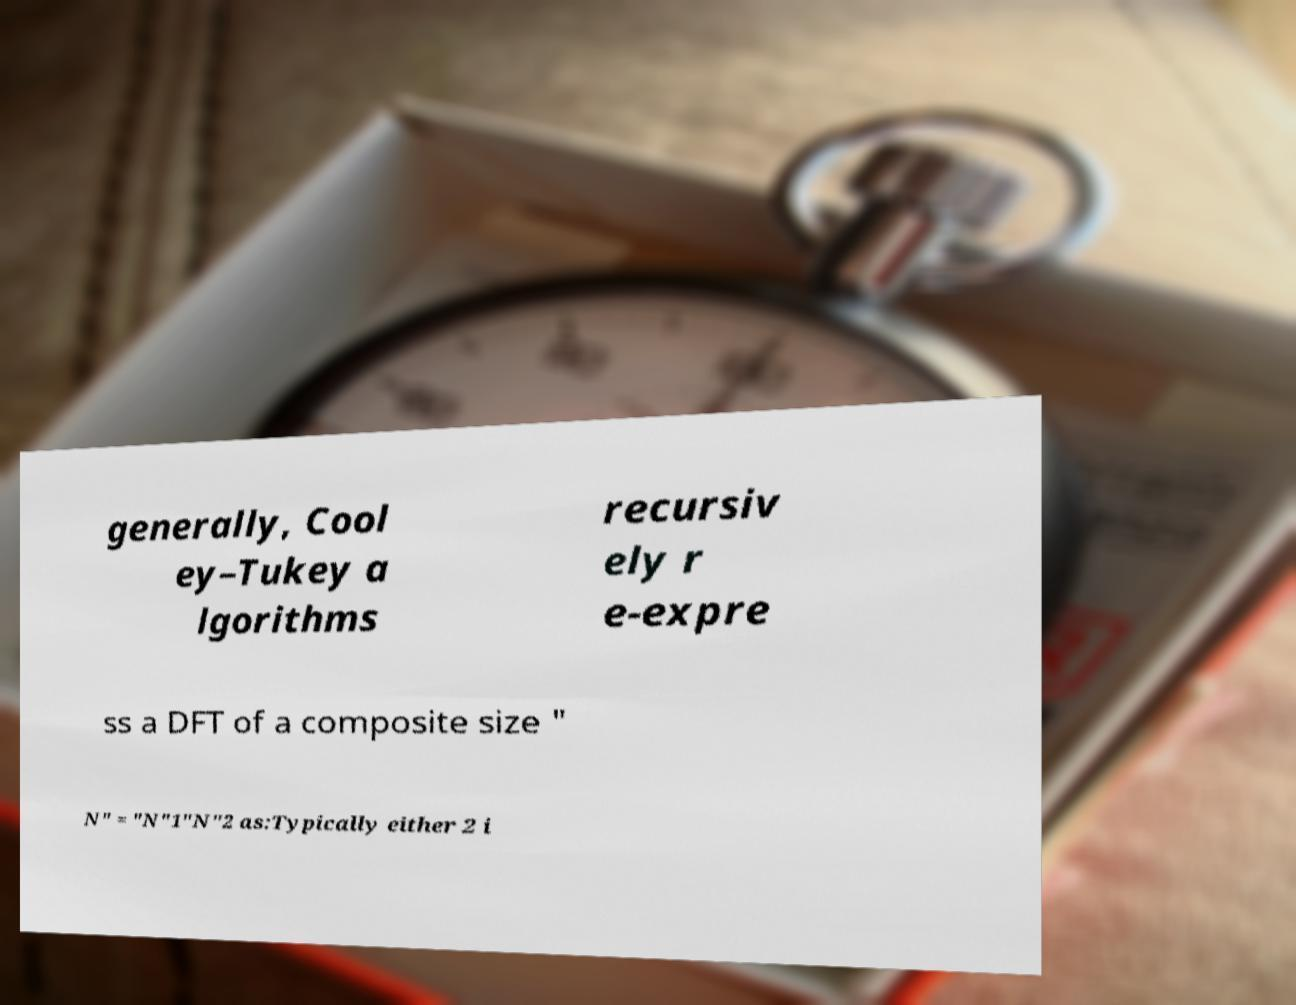For documentation purposes, I need the text within this image transcribed. Could you provide that? generally, Cool ey–Tukey a lgorithms recursiv ely r e-expre ss a DFT of a composite size " N" = "N"1"N"2 as:Typically either 2 i 